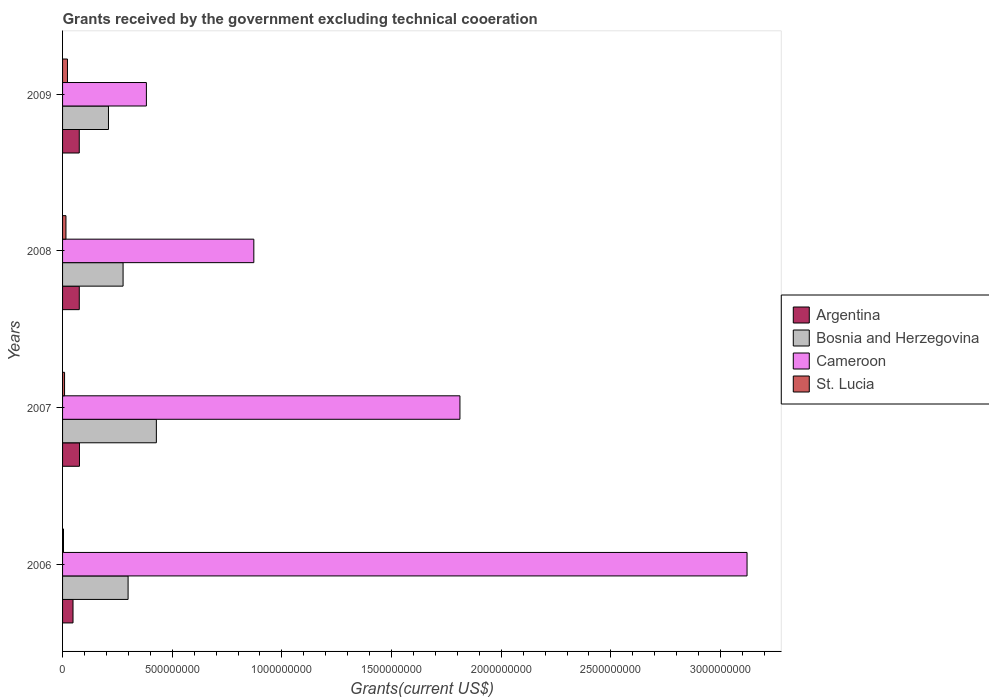How many groups of bars are there?
Your answer should be very brief. 4. Are the number of bars on each tick of the Y-axis equal?
Provide a succinct answer. Yes. How many bars are there on the 3rd tick from the bottom?
Ensure brevity in your answer.  4. What is the label of the 3rd group of bars from the top?
Offer a very short reply. 2007. In how many cases, is the number of bars for a given year not equal to the number of legend labels?
Your response must be concise. 0. What is the total grants received by the government in St. Lucia in 2009?
Give a very brief answer. 2.24e+07. Across all years, what is the maximum total grants received by the government in St. Lucia?
Ensure brevity in your answer.  2.24e+07. Across all years, what is the minimum total grants received by the government in Cameroon?
Your answer should be compact. 3.82e+08. In which year was the total grants received by the government in St. Lucia maximum?
Your answer should be compact. 2009. What is the total total grants received by the government in St. Lucia in the graph?
Your answer should be compact. 5.12e+07. What is the difference between the total grants received by the government in St. Lucia in 2008 and that in 2009?
Your answer should be very brief. -6.96e+06. What is the difference between the total grants received by the government in Cameroon in 2006 and the total grants received by the government in Bosnia and Herzegovina in 2008?
Make the answer very short. 2.84e+09. What is the average total grants received by the government in Bosnia and Herzegovina per year?
Offer a terse response. 3.03e+08. In the year 2007, what is the difference between the total grants received by the government in St. Lucia and total grants received by the government in Argentina?
Provide a succinct answer. -6.80e+07. What is the ratio of the total grants received by the government in Argentina in 2006 to that in 2007?
Your response must be concise. 0.62. Is the difference between the total grants received by the government in St. Lucia in 2007 and 2009 greater than the difference between the total grants received by the government in Argentina in 2007 and 2009?
Give a very brief answer. No. What is the difference between the highest and the second highest total grants received by the government in St. Lucia?
Ensure brevity in your answer.  6.96e+06. What is the difference between the highest and the lowest total grants received by the government in Cameroon?
Provide a short and direct response. 2.74e+09. In how many years, is the total grants received by the government in Argentina greater than the average total grants received by the government in Argentina taken over all years?
Provide a succinct answer. 3. What does the 1st bar from the top in 2007 represents?
Give a very brief answer. St. Lucia. Is it the case that in every year, the sum of the total grants received by the government in Bosnia and Herzegovina and total grants received by the government in St. Lucia is greater than the total grants received by the government in Argentina?
Give a very brief answer. Yes. How many years are there in the graph?
Give a very brief answer. 4. Does the graph contain grids?
Your answer should be very brief. No. Where does the legend appear in the graph?
Your answer should be compact. Center right. How are the legend labels stacked?
Keep it short and to the point. Vertical. What is the title of the graph?
Give a very brief answer. Grants received by the government excluding technical cooeration. Does "Egypt, Arab Rep." appear as one of the legend labels in the graph?
Offer a very short reply. No. What is the label or title of the X-axis?
Give a very brief answer. Grants(current US$). What is the label or title of the Y-axis?
Provide a short and direct response. Years. What is the Grants(current US$) of Argentina in 2006?
Provide a short and direct response. 4.76e+07. What is the Grants(current US$) of Bosnia and Herzegovina in 2006?
Your answer should be compact. 2.99e+08. What is the Grants(current US$) in Cameroon in 2006?
Provide a succinct answer. 3.12e+09. What is the Grants(current US$) of St. Lucia in 2006?
Your answer should be very brief. 4.23e+06. What is the Grants(current US$) of Argentina in 2007?
Ensure brevity in your answer.  7.71e+07. What is the Grants(current US$) in Bosnia and Herzegovina in 2007?
Offer a very short reply. 4.28e+08. What is the Grants(current US$) in Cameroon in 2007?
Make the answer very short. 1.81e+09. What is the Grants(current US$) of St. Lucia in 2007?
Offer a very short reply. 9.13e+06. What is the Grants(current US$) of Argentina in 2008?
Make the answer very short. 7.62e+07. What is the Grants(current US$) in Bosnia and Herzegovina in 2008?
Give a very brief answer. 2.76e+08. What is the Grants(current US$) in Cameroon in 2008?
Provide a short and direct response. 8.72e+08. What is the Grants(current US$) of St. Lucia in 2008?
Your answer should be compact. 1.54e+07. What is the Grants(current US$) of Argentina in 2009?
Provide a short and direct response. 7.62e+07. What is the Grants(current US$) in Bosnia and Herzegovina in 2009?
Provide a short and direct response. 2.09e+08. What is the Grants(current US$) of Cameroon in 2009?
Your response must be concise. 3.82e+08. What is the Grants(current US$) of St. Lucia in 2009?
Your answer should be very brief. 2.24e+07. Across all years, what is the maximum Grants(current US$) in Argentina?
Your response must be concise. 7.71e+07. Across all years, what is the maximum Grants(current US$) of Bosnia and Herzegovina?
Provide a short and direct response. 4.28e+08. Across all years, what is the maximum Grants(current US$) of Cameroon?
Ensure brevity in your answer.  3.12e+09. Across all years, what is the maximum Grants(current US$) in St. Lucia?
Your answer should be compact. 2.24e+07. Across all years, what is the minimum Grants(current US$) of Argentina?
Your answer should be compact. 4.76e+07. Across all years, what is the minimum Grants(current US$) of Bosnia and Herzegovina?
Offer a very short reply. 2.09e+08. Across all years, what is the minimum Grants(current US$) of Cameroon?
Offer a terse response. 3.82e+08. Across all years, what is the minimum Grants(current US$) in St. Lucia?
Give a very brief answer. 4.23e+06. What is the total Grants(current US$) in Argentina in the graph?
Provide a succinct answer. 2.77e+08. What is the total Grants(current US$) of Bosnia and Herzegovina in the graph?
Make the answer very short. 1.21e+09. What is the total Grants(current US$) in Cameroon in the graph?
Ensure brevity in your answer.  6.19e+09. What is the total Grants(current US$) in St. Lucia in the graph?
Your answer should be compact. 5.12e+07. What is the difference between the Grants(current US$) in Argentina in 2006 and that in 2007?
Offer a terse response. -2.94e+07. What is the difference between the Grants(current US$) of Bosnia and Herzegovina in 2006 and that in 2007?
Make the answer very short. -1.29e+08. What is the difference between the Grants(current US$) in Cameroon in 2006 and that in 2007?
Your response must be concise. 1.31e+09. What is the difference between the Grants(current US$) in St. Lucia in 2006 and that in 2007?
Offer a very short reply. -4.90e+06. What is the difference between the Grants(current US$) in Argentina in 2006 and that in 2008?
Your answer should be compact. -2.86e+07. What is the difference between the Grants(current US$) in Bosnia and Herzegovina in 2006 and that in 2008?
Keep it short and to the point. 2.29e+07. What is the difference between the Grants(current US$) in Cameroon in 2006 and that in 2008?
Keep it short and to the point. 2.25e+09. What is the difference between the Grants(current US$) in St. Lucia in 2006 and that in 2008?
Offer a terse response. -1.12e+07. What is the difference between the Grants(current US$) of Argentina in 2006 and that in 2009?
Ensure brevity in your answer.  -2.85e+07. What is the difference between the Grants(current US$) of Bosnia and Herzegovina in 2006 and that in 2009?
Offer a very short reply. 8.95e+07. What is the difference between the Grants(current US$) in Cameroon in 2006 and that in 2009?
Ensure brevity in your answer.  2.74e+09. What is the difference between the Grants(current US$) of St. Lucia in 2006 and that in 2009?
Provide a succinct answer. -1.82e+07. What is the difference between the Grants(current US$) of Argentina in 2007 and that in 2008?
Your answer should be very brief. 8.50e+05. What is the difference between the Grants(current US$) of Bosnia and Herzegovina in 2007 and that in 2008?
Keep it short and to the point. 1.52e+08. What is the difference between the Grants(current US$) in Cameroon in 2007 and that in 2008?
Your response must be concise. 9.40e+08. What is the difference between the Grants(current US$) in St. Lucia in 2007 and that in 2008?
Offer a terse response. -6.29e+06. What is the difference between the Grants(current US$) in Argentina in 2007 and that in 2009?
Ensure brevity in your answer.  9.10e+05. What is the difference between the Grants(current US$) in Bosnia and Herzegovina in 2007 and that in 2009?
Make the answer very short. 2.18e+08. What is the difference between the Grants(current US$) of Cameroon in 2007 and that in 2009?
Your answer should be very brief. 1.43e+09. What is the difference between the Grants(current US$) in St. Lucia in 2007 and that in 2009?
Your answer should be compact. -1.32e+07. What is the difference between the Grants(current US$) of Bosnia and Herzegovina in 2008 and that in 2009?
Your answer should be very brief. 6.67e+07. What is the difference between the Grants(current US$) of Cameroon in 2008 and that in 2009?
Ensure brevity in your answer.  4.90e+08. What is the difference between the Grants(current US$) of St. Lucia in 2008 and that in 2009?
Your answer should be compact. -6.96e+06. What is the difference between the Grants(current US$) in Argentina in 2006 and the Grants(current US$) in Bosnia and Herzegovina in 2007?
Your answer should be very brief. -3.80e+08. What is the difference between the Grants(current US$) in Argentina in 2006 and the Grants(current US$) in Cameroon in 2007?
Your answer should be very brief. -1.76e+09. What is the difference between the Grants(current US$) of Argentina in 2006 and the Grants(current US$) of St. Lucia in 2007?
Keep it short and to the point. 3.85e+07. What is the difference between the Grants(current US$) in Bosnia and Herzegovina in 2006 and the Grants(current US$) in Cameroon in 2007?
Give a very brief answer. -1.51e+09. What is the difference between the Grants(current US$) in Bosnia and Herzegovina in 2006 and the Grants(current US$) in St. Lucia in 2007?
Make the answer very short. 2.90e+08. What is the difference between the Grants(current US$) of Cameroon in 2006 and the Grants(current US$) of St. Lucia in 2007?
Ensure brevity in your answer.  3.11e+09. What is the difference between the Grants(current US$) of Argentina in 2006 and the Grants(current US$) of Bosnia and Herzegovina in 2008?
Your response must be concise. -2.28e+08. What is the difference between the Grants(current US$) in Argentina in 2006 and the Grants(current US$) in Cameroon in 2008?
Ensure brevity in your answer.  -8.24e+08. What is the difference between the Grants(current US$) of Argentina in 2006 and the Grants(current US$) of St. Lucia in 2008?
Ensure brevity in your answer.  3.22e+07. What is the difference between the Grants(current US$) of Bosnia and Herzegovina in 2006 and the Grants(current US$) of Cameroon in 2008?
Offer a terse response. -5.73e+08. What is the difference between the Grants(current US$) in Bosnia and Herzegovina in 2006 and the Grants(current US$) in St. Lucia in 2008?
Your answer should be compact. 2.83e+08. What is the difference between the Grants(current US$) of Cameroon in 2006 and the Grants(current US$) of St. Lucia in 2008?
Make the answer very short. 3.11e+09. What is the difference between the Grants(current US$) of Argentina in 2006 and the Grants(current US$) of Bosnia and Herzegovina in 2009?
Ensure brevity in your answer.  -1.62e+08. What is the difference between the Grants(current US$) in Argentina in 2006 and the Grants(current US$) in Cameroon in 2009?
Make the answer very short. -3.35e+08. What is the difference between the Grants(current US$) of Argentina in 2006 and the Grants(current US$) of St. Lucia in 2009?
Provide a short and direct response. 2.52e+07. What is the difference between the Grants(current US$) of Bosnia and Herzegovina in 2006 and the Grants(current US$) of Cameroon in 2009?
Your answer should be very brief. -8.34e+07. What is the difference between the Grants(current US$) in Bosnia and Herzegovina in 2006 and the Grants(current US$) in St. Lucia in 2009?
Make the answer very short. 2.76e+08. What is the difference between the Grants(current US$) in Cameroon in 2006 and the Grants(current US$) in St. Lucia in 2009?
Ensure brevity in your answer.  3.10e+09. What is the difference between the Grants(current US$) of Argentina in 2007 and the Grants(current US$) of Bosnia and Herzegovina in 2008?
Offer a very short reply. -1.99e+08. What is the difference between the Grants(current US$) in Argentina in 2007 and the Grants(current US$) in Cameroon in 2008?
Provide a short and direct response. -7.95e+08. What is the difference between the Grants(current US$) of Argentina in 2007 and the Grants(current US$) of St. Lucia in 2008?
Offer a terse response. 6.17e+07. What is the difference between the Grants(current US$) of Bosnia and Herzegovina in 2007 and the Grants(current US$) of Cameroon in 2008?
Your answer should be compact. -4.44e+08. What is the difference between the Grants(current US$) of Bosnia and Herzegovina in 2007 and the Grants(current US$) of St. Lucia in 2008?
Make the answer very short. 4.12e+08. What is the difference between the Grants(current US$) of Cameroon in 2007 and the Grants(current US$) of St. Lucia in 2008?
Make the answer very short. 1.80e+09. What is the difference between the Grants(current US$) of Argentina in 2007 and the Grants(current US$) of Bosnia and Herzegovina in 2009?
Provide a short and direct response. -1.32e+08. What is the difference between the Grants(current US$) in Argentina in 2007 and the Grants(current US$) in Cameroon in 2009?
Ensure brevity in your answer.  -3.05e+08. What is the difference between the Grants(current US$) of Argentina in 2007 and the Grants(current US$) of St. Lucia in 2009?
Keep it short and to the point. 5.47e+07. What is the difference between the Grants(current US$) in Bosnia and Herzegovina in 2007 and the Grants(current US$) in Cameroon in 2009?
Keep it short and to the point. 4.55e+07. What is the difference between the Grants(current US$) in Bosnia and Herzegovina in 2007 and the Grants(current US$) in St. Lucia in 2009?
Your answer should be compact. 4.05e+08. What is the difference between the Grants(current US$) of Cameroon in 2007 and the Grants(current US$) of St. Lucia in 2009?
Offer a terse response. 1.79e+09. What is the difference between the Grants(current US$) in Argentina in 2008 and the Grants(current US$) in Bosnia and Herzegovina in 2009?
Offer a very short reply. -1.33e+08. What is the difference between the Grants(current US$) of Argentina in 2008 and the Grants(current US$) of Cameroon in 2009?
Your answer should be very brief. -3.06e+08. What is the difference between the Grants(current US$) of Argentina in 2008 and the Grants(current US$) of St. Lucia in 2009?
Ensure brevity in your answer.  5.38e+07. What is the difference between the Grants(current US$) of Bosnia and Herzegovina in 2008 and the Grants(current US$) of Cameroon in 2009?
Your answer should be compact. -1.06e+08. What is the difference between the Grants(current US$) in Bosnia and Herzegovina in 2008 and the Grants(current US$) in St. Lucia in 2009?
Provide a short and direct response. 2.54e+08. What is the difference between the Grants(current US$) of Cameroon in 2008 and the Grants(current US$) of St. Lucia in 2009?
Provide a succinct answer. 8.50e+08. What is the average Grants(current US$) in Argentina per year?
Your response must be concise. 6.93e+07. What is the average Grants(current US$) in Bosnia and Herzegovina per year?
Provide a succinct answer. 3.03e+08. What is the average Grants(current US$) of Cameroon per year?
Offer a very short reply. 1.55e+09. What is the average Grants(current US$) in St. Lucia per year?
Give a very brief answer. 1.28e+07. In the year 2006, what is the difference between the Grants(current US$) in Argentina and Grants(current US$) in Bosnia and Herzegovina?
Ensure brevity in your answer.  -2.51e+08. In the year 2006, what is the difference between the Grants(current US$) in Argentina and Grants(current US$) in Cameroon?
Ensure brevity in your answer.  -3.07e+09. In the year 2006, what is the difference between the Grants(current US$) of Argentina and Grants(current US$) of St. Lucia?
Ensure brevity in your answer.  4.34e+07. In the year 2006, what is the difference between the Grants(current US$) in Bosnia and Herzegovina and Grants(current US$) in Cameroon?
Offer a terse response. -2.82e+09. In the year 2006, what is the difference between the Grants(current US$) of Bosnia and Herzegovina and Grants(current US$) of St. Lucia?
Offer a terse response. 2.95e+08. In the year 2006, what is the difference between the Grants(current US$) in Cameroon and Grants(current US$) in St. Lucia?
Your answer should be very brief. 3.12e+09. In the year 2007, what is the difference between the Grants(current US$) of Argentina and Grants(current US$) of Bosnia and Herzegovina?
Offer a terse response. -3.51e+08. In the year 2007, what is the difference between the Grants(current US$) in Argentina and Grants(current US$) in Cameroon?
Offer a very short reply. -1.73e+09. In the year 2007, what is the difference between the Grants(current US$) of Argentina and Grants(current US$) of St. Lucia?
Provide a succinct answer. 6.80e+07. In the year 2007, what is the difference between the Grants(current US$) of Bosnia and Herzegovina and Grants(current US$) of Cameroon?
Your answer should be compact. -1.38e+09. In the year 2007, what is the difference between the Grants(current US$) in Bosnia and Herzegovina and Grants(current US$) in St. Lucia?
Your response must be concise. 4.19e+08. In the year 2007, what is the difference between the Grants(current US$) of Cameroon and Grants(current US$) of St. Lucia?
Your answer should be very brief. 1.80e+09. In the year 2008, what is the difference between the Grants(current US$) in Argentina and Grants(current US$) in Bosnia and Herzegovina?
Offer a very short reply. -2.00e+08. In the year 2008, what is the difference between the Grants(current US$) in Argentina and Grants(current US$) in Cameroon?
Provide a succinct answer. -7.96e+08. In the year 2008, what is the difference between the Grants(current US$) in Argentina and Grants(current US$) in St. Lucia?
Your answer should be compact. 6.08e+07. In the year 2008, what is the difference between the Grants(current US$) in Bosnia and Herzegovina and Grants(current US$) in Cameroon?
Your response must be concise. -5.96e+08. In the year 2008, what is the difference between the Grants(current US$) in Bosnia and Herzegovina and Grants(current US$) in St. Lucia?
Your answer should be very brief. 2.60e+08. In the year 2008, what is the difference between the Grants(current US$) of Cameroon and Grants(current US$) of St. Lucia?
Keep it short and to the point. 8.57e+08. In the year 2009, what is the difference between the Grants(current US$) of Argentina and Grants(current US$) of Bosnia and Herzegovina?
Your answer should be very brief. -1.33e+08. In the year 2009, what is the difference between the Grants(current US$) in Argentina and Grants(current US$) in Cameroon?
Give a very brief answer. -3.06e+08. In the year 2009, what is the difference between the Grants(current US$) of Argentina and Grants(current US$) of St. Lucia?
Your answer should be compact. 5.38e+07. In the year 2009, what is the difference between the Grants(current US$) of Bosnia and Herzegovina and Grants(current US$) of Cameroon?
Ensure brevity in your answer.  -1.73e+08. In the year 2009, what is the difference between the Grants(current US$) in Bosnia and Herzegovina and Grants(current US$) in St. Lucia?
Offer a very short reply. 1.87e+08. In the year 2009, what is the difference between the Grants(current US$) in Cameroon and Grants(current US$) in St. Lucia?
Your answer should be very brief. 3.60e+08. What is the ratio of the Grants(current US$) of Argentina in 2006 to that in 2007?
Offer a terse response. 0.62. What is the ratio of the Grants(current US$) of Bosnia and Herzegovina in 2006 to that in 2007?
Keep it short and to the point. 0.7. What is the ratio of the Grants(current US$) in Cameroon in 2006 to that in 2007?
Make the answer very short. 1.72. What is the ratio of the Grants(current US$) in St. Lucia in 2006 to that in 2007?
Provide a succinct answer. 0.46. What is the ratio of the Grants(current US$) of Argentina in 2006 to that in 2008?
Your answer should be very brief. 0.62. What is the ratio of the Grants(current US$) of Bosnia and Herzegovina in 2006 to that in 2008?
Ensure brevity in your answer.  1.08. What is the ratio of the Grants(current US$) of Cameroon in 2006 to that in 2008?
Your response must be concise. 3.58. What is the ratio of the Grants(current US$) of St. Lucia in 2006 to that in 2008?
Provide a short and direct response. 0.27. What is the ratio of the Grants(current US$) of Argentina in 2006 to that in 2009?
Offer a terse response. 0.63. What is the ratio of the Grants(current US$) in Bosnia and Herzegovina in 2006 to that in 2009?
Offer a very short reply. 1.43. What is the ratio of the Grants(current US$) in Cameroon in 2006 to that in 2009?
Keep it short and to the point. 8.17. What is the ratio of the Grants(current US$) in St. Lucia in 2006 to that in 2009?
Give a very brief answer. 0.19. What is the ratio of the Grants(current US$) in Argentina in 2007 to that in 2008?
Offer a terse response. 1.01. What is the ratio of the Grants(current US$) of Bosnia and Herzegovina in 2007 to that in 2008?
Ensure brevity in your answer.  1.55. What is the ratio of the Grants(current US$) of Cameroon in 2007 to that in 2008?
Offer a terse response. 2.08. What is the ratio of the Grants(current US$) in St. Lucia in 2007 to that in 2008?
Keep it short and to the point. 0.59. What is the ratio of the Grants(current US$) of Argentina in 2007 to that in 2009?
Ensure brevity in your answer.  1.01. What is the ratio of the Grants(current US$) in Bosnia and Herzegovina in 2007 to that in 2009?
Give a very brief answer. 2.04. What is the ratio of the Grants(current US$) in Cameroon in 2007 to that in 2009?
Offer a very short reply. 4.74. What is the ratio of the Grants(current US$) of St. Lucia in 2007 to that in 2009?
Your answer should be very brief. 0.41. What is the ratio of the Grants(current US$) in Bosnia and Herzegovina in 2008 to that in 2009?
Give a very brief answer. 1.32. What is the ratio of the Grants(current US$) in Cameroon in 2008 to that in 2009?
Your response must be concise. 2.28. What is the ratio of the Grants(current US$) in St. Lucia in 2008 to that in 2009?
Provide a short and direct response. 0.69. What is the difference between the highest and the second highest Grants(current US$) of Argentina?
Offer a terse response. 8.50e+05. What is the difference between the highest and the second highest Grants(current US$) in Bosnia and Herzegovina?
Your answer should be compact. 1.29e+08. What is the difference between the highest and the second highest Grants(current US$) of Cameroon?
Provide a succinct answer. 1.31e+09. What is the difference between the highest and the second highest Grants(current US$) of St. Lucia?
Make the answer very short. 6.96e+06. What is the difference between the highest and the lowest Grants(current US$) in Argentina?
Your response must be concise. 2.94e+07. What is the difference between the highest and the lowest Grants(current US$) in Bosnia and Herzegovina?
Your response must be concise. 2.18e+08. What is the difference between the highest and the lowest Grants(current US$) of Cameroon?
Offer a terse response. 2.74e+09. What is the difference between the highest and the lowest Grants(current US$) in St. Lucia?
Make the answer very short. 1.82e+07. 